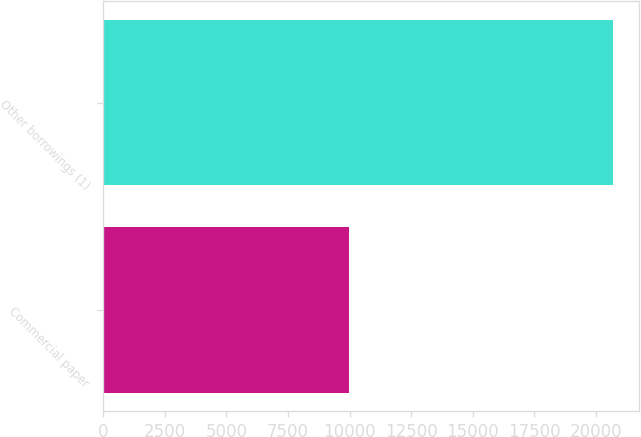<chart> <loc_0><loc_0><loc_500><loc_500><bar_chart><fcel>Commercial paper<fcel>Other borrowings (1)<nl><fcel>9989<fcel>20712<nl></chart> 